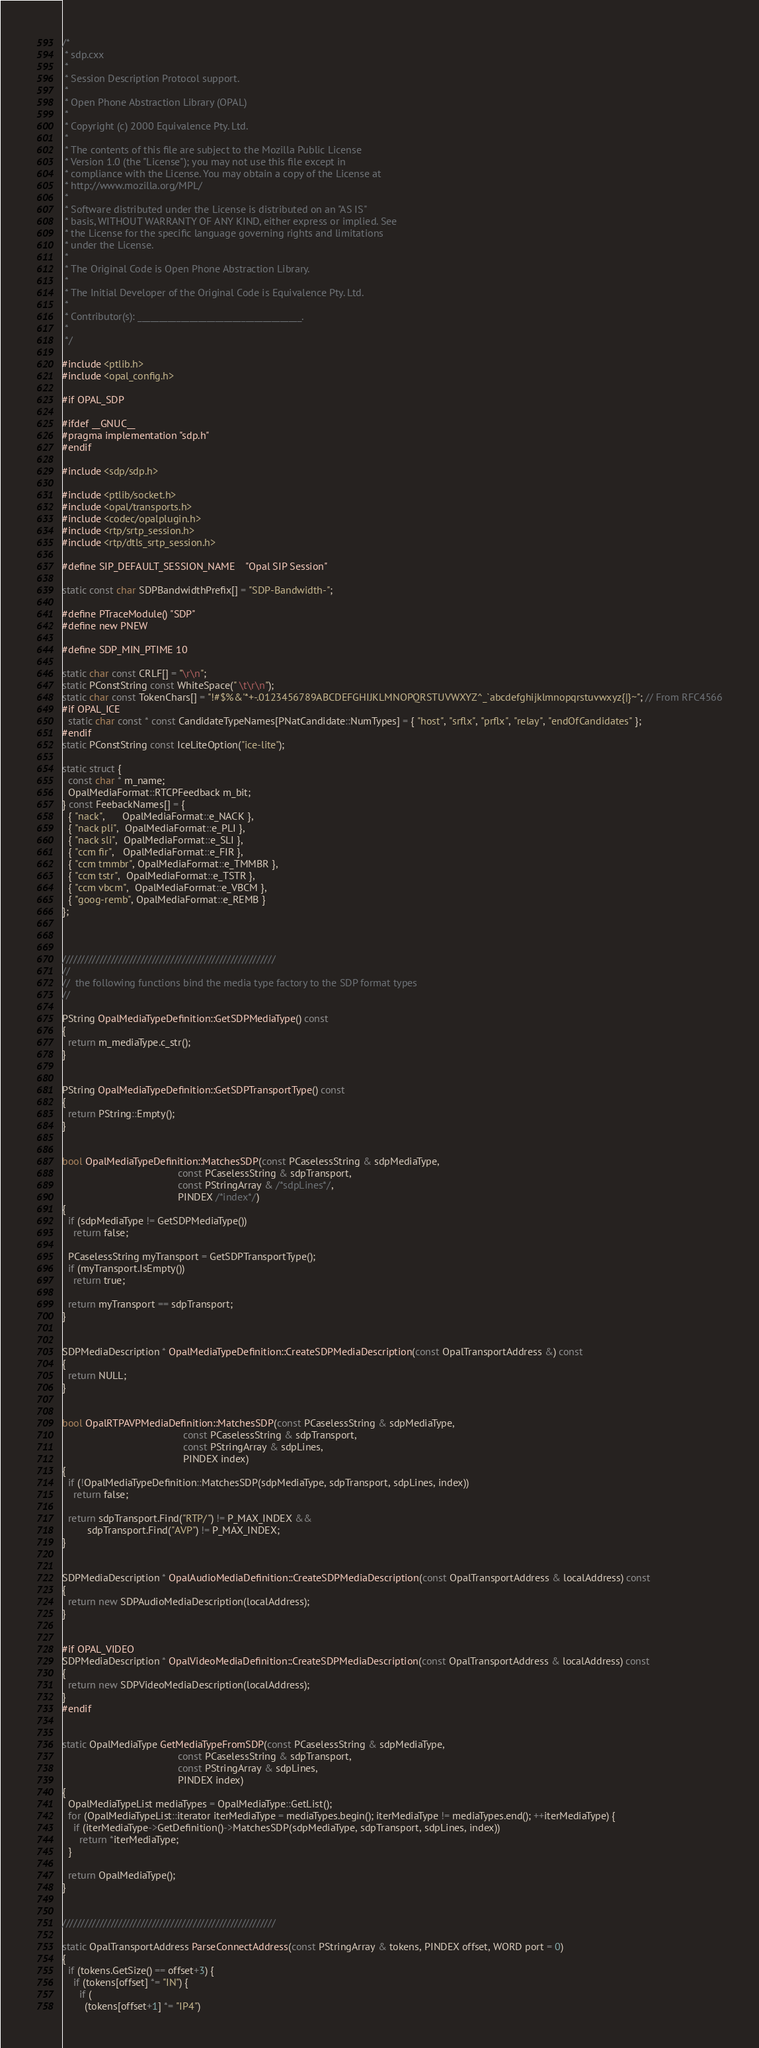<code> <loc_0><loc_0><loc_500><loc_500><_C++_>/*
 * sdp.cxx
 *
 * Session Description Protocol support.
 *
 * Open Phone Abstraction Library (OPAL)
 *
 * Copyright (c) 2000 Equivalence Pty. Ltd.
 *
 * The contents of this file are subject to the Mozilla Public License
 * Version 1.0 (the "License"); you may not use this file except in
 * compliance with the License. You may obtain a copy of the License at
 * http://www.mozilla.org/MPL/
 *
 * Software distributed under the License is distributed on an "AS IS"
 * basis, WITHOUT WARRANTY OF ANY KIND, either express or implied. See
 * the License for the specific language governing rights and limitations
 * under the License.
 *
 * The Original Code is Open Phone Abstraction Library.
 *
 * The Initial Developer of the Original Code is Equivalence Pty. Ltd.
 *
 * Contributor(s): ______________________________________.
 *
 */

#include <ptlib.h>
#include <opal_config.h>

#if OPAL_SDP

#ifdef __GNUC__
#pragma implementation "sdp.h"
#endif

#include <sdp/sdp.h>

#include <ptlib/socket.h>
#include <opal/transports.h>
#include <codec/opalplugin.h>
#include <rtp/srtp_session.h>
#include <rtp/dtls_srtp_session.h>

#define SIP_DEFAULT_SESSION_NAME    "Opal SIP Session"

static const char SDPBandwidthPrefix[] = "SDP-Bandwidth-";

#define PTraceModule() "SDP"
#define new PNEW

#define SDP_MIN_PTIME 10

static char const CRLF[] = "\r\n";
static PConstString const WhiteSpace(" \t\r\n");
static char const TokenChars[] = "!#$%&'*+-.0123456789ABCDEFGHIJKLMNOPQRSTUVWXYZ^_`abcdefghijklmnopqrstuvwxyz{|}~"; // From RFC4566
#if OPAL_ICE
  static char const * const CandidateTypeNames[PNatCandidate::NumTypes] = { "host", "srflx", "prflx", "relay", "endOfCandidates" };
#endif
static PConstString const IceLiteOption("ice-lite");

static struct {
  const char * m_name;
  OpalMediaFormat::RTCPFeedback m_bit;
} const FeebackNames[] = {
  { "nack",      OpalMediaFormat::e_NACK },
  { "nack pli",  OpalMediaFormat::e_PLI },
  { "nack sli",  OpalMediaFormat::e_SLI },
  { "ccm fir",   OpalMediaFormat::e_FIR },
  { "ccm tmmbr", OpalMediaFormat::e_TMMBR },
  { "ccm tstr",  OpalMediaFormat::e_TSTR },
  { "ccm vbcm",  OpalMediaFormat::e_VBCM },
  { "goog-remb", OpalMediaFormat::e_REMB }
};



/////////////////////////////////////////////////////////
//
//  the following functions bind the media type factory to the SDP format types
//

PString OpalMediaTypeDefinition::GetSDPMediaType() const
{
  return m_mediaType.c_str();
}


PString OpalMediaTypeDefinition::GetSDPTransportType() const
{
  return PString::Empty();
}


bool OpalMediaTypeDefinition::MatchesSDP(const PCaselessString & sdpMediaType,
                                         const PCaselessString & sdpTransport,
                                         const PStringArray & /*sdpLines*/,
                                         PINDEX /*index*/)
{
  if (sdpMediaType != GetSDPMediaType())
    return false;

  PCaselessString myTransport = GetSDPTransportType();
  if (myTransport.IsEmpty())
    return true;

  return myTransport == sdpTransport;
}


SDPMediaDescription * OpalMediaTypeDefinition::CreateSDPMediaDescription(const OpalTransportAddress &) const
{
  return NULL;
}


bool OpalRTPAVPMediaDefinition::MatchesSDP(const PCaselessString & sdpMediaType,
                                           const PCaselessString & sdpTransport,
                                           const PStringArray & sdpLines,
                                           PINDEX index)
{
  if (!OpalMediaTypeDefinition::MatchesSDP(sdpMediaType, sdpTransport, sdpLines, index))
    return false;

  return sdpTransport.Find("RTP/") != P_MAX_INDEX &&
         sdpTransport.Find("AVP") != P_MAX_INDEX;
}


SDPMediaDescription * OpalAudioMediaDefinition::CreateSDPMediaDescription(const OpalTransportAddress & localAddress) const
{
  return new SDPAudioMediaDescription(localAddress);
}


#if OPAL_VIDEO
SDPMediaDescription * OpalVideoMediaDefinition::CreateSDPMediaDescription(const OpalTransportAddress & localAddress) const
{
  return new SDPVideoMediaDescription(localAddress);
}
#endif


static OpalMediaType GetMediaTypeFromSDP(const PCaselessString & sdpMediaType,
                                         const PCaselessString & sdpTransport,
                                         const PStringArray & sdpLines,
                                         PINDEX index)
{
  OpalMediaTypeList mediaTypes = OpalMediaType::GetList();
  for (OpalMediaTypeList::iterator iterMediaType = mediaTypes.begin(); iterMediaType != mediaTypes.end(); ++iterMediaType) {
    if (iterMediaType->GetDefinition()->MatchesSDP(sdpMediaType, sdpTransport, sdpLines, index))
      return *iterMediaType;
  }

  return OpalMediaType();
}


/////////////////////////////////////////////////////////

static OpalTransportAddress ParseConnectAddress(const PStringArray & tokens, PINDEX offset, WORD port = 0)
{
  if (tokens.GetSize() == offset+3) {
    if (tokens[offset] *= "IN") {
      if (
        (tokens[offset+1] *= "IP4")</code> 